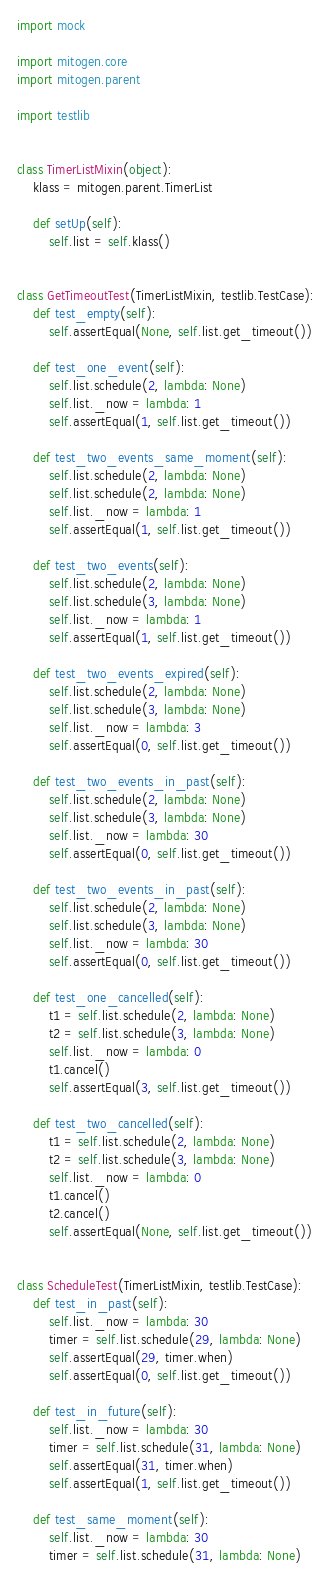Convert code to text. <code><loc_0><loc_0><loc_500><loc_500><_Python_>import mock

import mitogen.core
import mitogen.parent

import testlib


class TimerListMixin(object):
    klass = mitogen.parent.TimerList

    def setUp(self):
        self.list = self.klass()


class GetTimeoutTest(TimerListMixin, testlib.TestCase):
    def test_empty(self):
        self.assertEqual(None, self.list.get_timeout())

    def test_one_event(self):
        self.list.schedule(2, lambda: None)
        self.list._now = lambda: 1
        self.assertEqual(1, self.list.get_timeout())

    def test_two_events_same_moment(self):
        self.list.schedule(2, lambda: None)
        self.list.schedule(2, lambda: None)
        self.list._now = lambda: 1
        self.assertEqual(1, self.list.get_timeout())

    def test_two_events(self):
        self.list.schedule(2, lambda: None)
        self.list.schedule(3, lambda: None)
        self.list._now = lambda: 1
        self.assertEqual(1, self.list.get_timeout())

    def test_two_events_expired(self):
        self.list.schedule(2, lambda: None)
        self.list.schedule(3, lambda: None)
        self.list._now = lambda: 3
        self.assertEqual(0, self.list.get_timeout())

    def test_two_events_in_past(self):
        self.list.schedule(2, lambda: None)
        self.list.schedule(3, lambda: None)
        self.list._now = lambda: 30
        self.assertEqual(0, self.list.get_timeout())

    def test_two_events_in_past(self):
        self.list.schedule(2, lambda: None)
        self.list.schedule(3, lambda: None)
        self.list._now = lambda: 30
        self.assertEqual(0, self.list.get_timeout())

    def test_one_cancelled(self):
        t1 = self.list.schedule(2, lambda: None)
        t2 = self.list.schedule(3, lambda: None)
        self.list._now = lambda: 0
        t1.cancel()
        self.assertEqual(3, self.list.get_timeout())

    def test_two_cancelled(self):
        t1 = self.list.schedule(2, lambda: None)
        t2 = self.list.schedule(3, lambda: None)
        self.list._now = lambda: 0
        t1.cancel()
        t2.cancel()
        self.assertEqual(None, self.list.get_timeout())


class ScheduleTest(TimerListMixin, testlib.TestCase):
    def test_in_past(self):
        self.list._now = lambda: 30
        timer = self.list.schedule(29, lambda: None)
        self.assertEqual(29, timer.when)
        self.assertEqual(0, self.list.get_timeout())

    def test_in_future(self):
        self.list._now = lambda: 30
        timer = self.list.schedule(31, lambda: None)
        self.assertEqual(31, timer.when)
        self.assertEqual(1, self.list.get_timeout())

    def test_same_moment(self):
        self.list._now = lambda: 30
        timer = self.list.schedule(31, lambda: None)</code> 